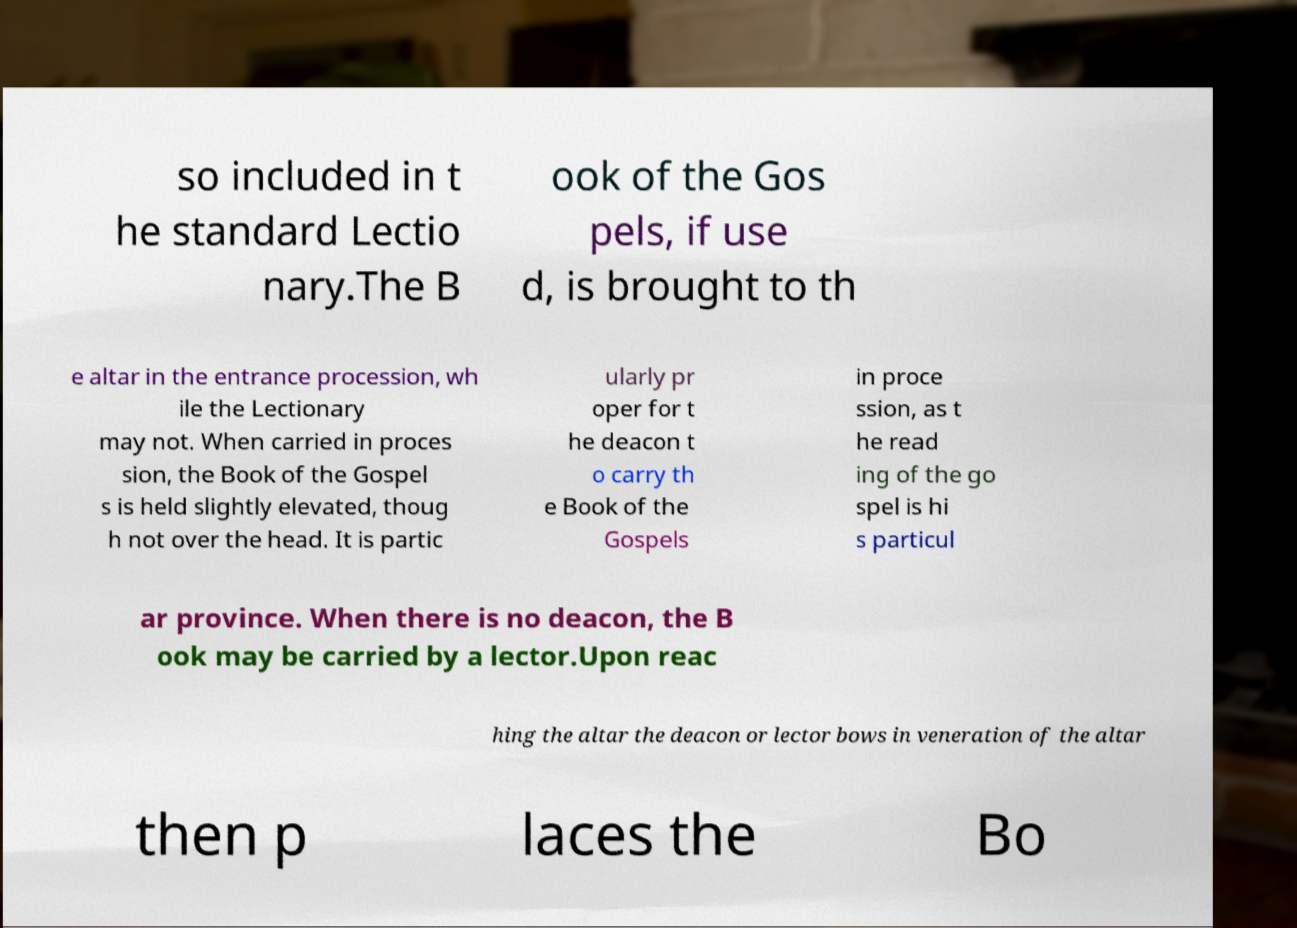Could you extract and type out the text from this image? so included in t he standard Lectio nary.The B ook of the Gos pels, if use d, is brought to th e altar in the entrance procession, wh ile the Lectionary may not. When carried in proces sion, the Book of the Gospel s is held slightly elevated, thoug h not over the head. It is partic ularly pr oper for t he deacon t o carry th e Book of the Gospels in proce ssion, as t he read ing of the go spel is hi s particul ar province. When there is no deacon, the B ook may be carried by a lector.Upon reac hing the altar the deacon or lector bows in veneration of the altar then p laces the Bo 